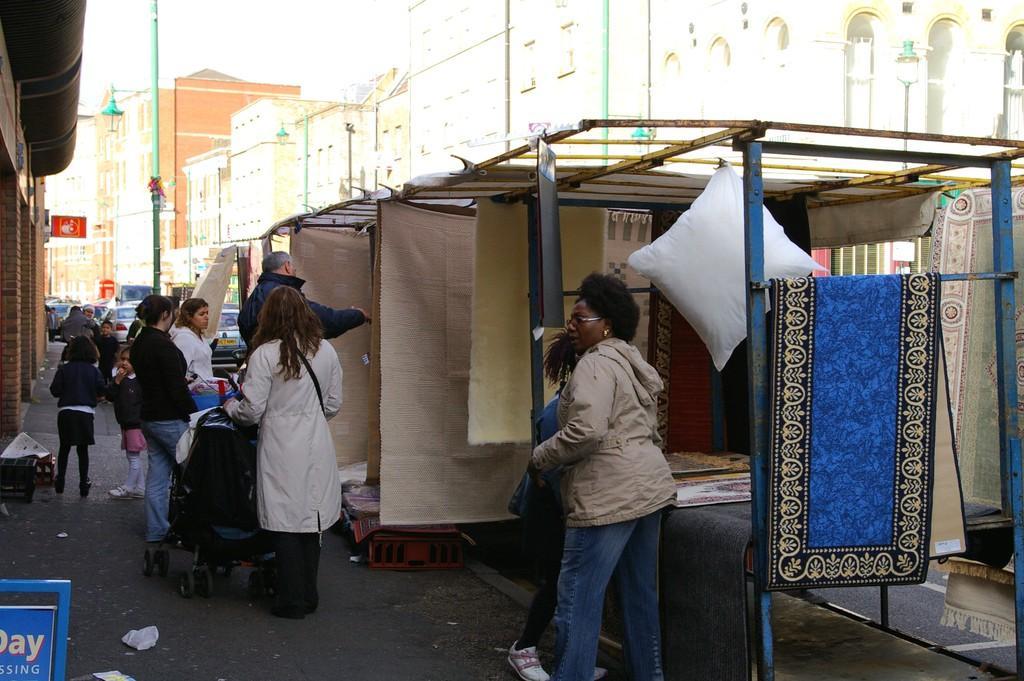Can you describe this image briefly? In this image we can see the buildings and the street lights. And we can see some people near the stall. And we can see some vehicles. 